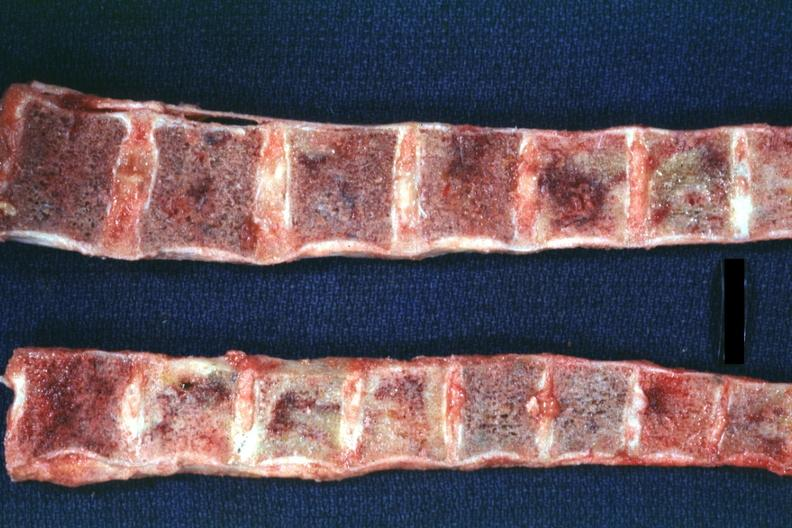what is present?
Answer the question using a single word or phrase. Joints 